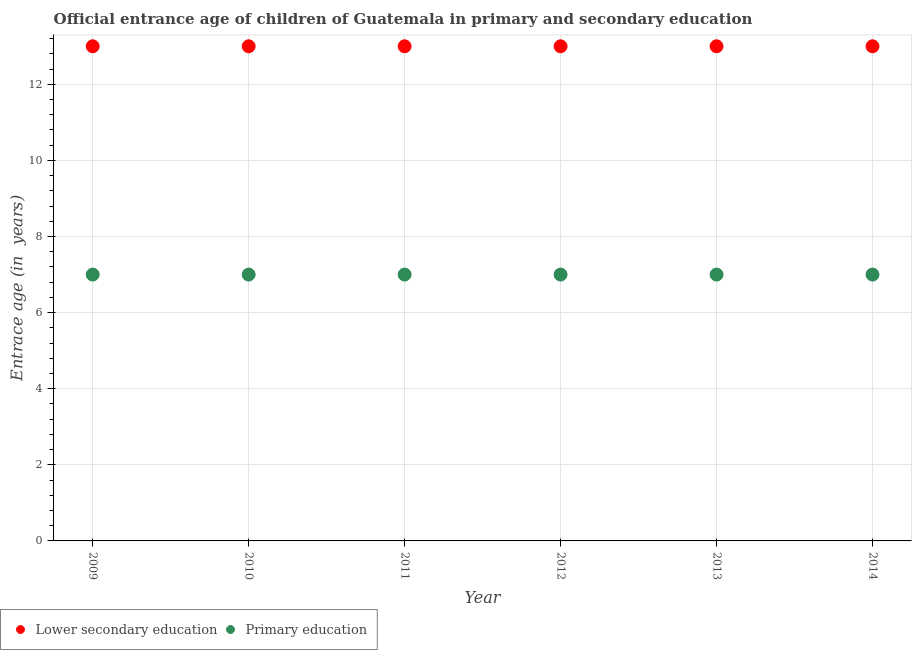Is the number of dotlines equal to the number of legend labels?
Your answer should be compact. Yes. What is the entrance age of children in lower secondary education in 2011?
Provide a short and direct response. 13. Across all years, what is the maximum entrance age of chiildren in primary education?
Keep it short and to the point. 7. Across all years, what is the minimum entrance age of children in lower secondary education?
Make the answer very short. 13. In which year was the entrance age of chiildren in primary education maximum?
Your response must be concise. 2009. In which year was the entrance age of chiildren in primary education minimum?
Provide a short and direct response. 2009. What is the total entrance age of children in lower secondary education in the graph?
Provide a short and direct response. 78. In the year 2011, what is the difference between the entrance age of children in lower secondary education and entrance age of chiildren in primary education?
Your answer should be compact. 6. In how many years, is the entrance age of chiildren in primary education greater than 7.6 years?
Provide a succinct answer. 0. What is the ratio of the entrance age of children in lower secondary education in 2011 to that in 2012?
Provide a short and direct response. 1. What is the difference between the highest and the second highest entrance age of chiildren in primary education?
Provide a succinct answer. 0. What is the difference between the highest and the lowest entrance age of chiildren in primary education?
Provide a succinct answer. 0. In how many years, is the entrance age of children in lower secondary education greater than the average entrance age of children in lower secondary education taken over all years?
Make the answer very short. 0. Does the entrance age of children in lower secondary education monotonically increase over the years?
Your answer should be compact. No. Is the entrance age of chiildren in primary education strictly greater than the entrance age of children in lower secondary education over the years?
Ensure brevity in your answer.  No. Is the entrance age of children in lower secondary education strictly less than the entrance age of chiildren in primary education over the years?
Your answer should be compact. No. How many dotlines are there?
Your answer should be compact. 2. Are the values on the major ticks of Y-axis written in scientific E-notation?
Keep it short and to the point. No. Does the graph contain grids?
Provide a short and direct response. Yes. How many legend labels are there?
Give a very brief answer. 2. What is the title of the graph?
Your answer should be very brief. Official entrance age of children of Guatemala in primary and secondary education. What is the label or title of the Y-axis?
Provide a succinct answer. Entrace age (in  years). What is the Entrace age (in  years) in Primary education in 2009?
Keep it short and to the point. 7. What is the Entrace age (in  years) in Primary education in 2010?
Offer a very short reply. 7. What is the Entrace age (in  years) in Lower secondary education in 2012?
Make the answer very short. 13. What is the Entrace age (in  years) in Primary education in 2012?
Ensure brevity in your answer.  7. What is the Entrace age (in  years) of Primary education in 2013?
Ensure brevity in your answer.  7. What is the Entrace age (in  years) of Primary education in 2014?
Your answer should be compact. 7. Across all years, what is the maximum Entrace age (in  years) in Lower secondary education?
Your answer should be compact. 13. What is the difference between the Entrace age (in  years) in Lower secondary education in 2009 and that in 2011?
Your answer should be compact. 0. What is the difference between the Entrace age (in  years) in Primary education in 2009 and that in 2013?
Provide a succinct answer. 0. What is the difference between the Entrace age (in  years) of Primary education in 2009 and that in 2014?
Keep it short and to the point. 0. What is the difference between the Entrace age (in  years) of Primary education in 2010 and that in 2011?
Your response must be concise. 0. What is the difference between the Entrace age (in  years) of Lower secondary education in 2010 and that in 2012?
Provide a succinct answer. 0. What is the difference between the Entrace age (in  years) of Lower secondary education in 2010 and that in 2013?
Your answer should be very brief. 0. What is the difference between the Entrace age (in  years) in Lower secondary education in 2010 and that in 2014?
Offer a terse response. 0. What is the difference between the Entrace age (in  years) of Primary education in 2010 and that in 2014?
Your answer should be very brief. 0. What is the difference between the Entrace age (in  years) in Lower secondary education in 2011 and that in 2013?
Your answer should be very brief. 0. What is the difference between the Entrace age (in  years) in Primary education in 2011 and that in 2013?
Your response must be concise. 0. What is the difference between the Entrace age (in  years) in Primary education in 2012 and that in 2013?
Your answer should be compact. 0. What is the difference between the Entrace age (in  years) in Lower secondary education in 2012 and that in 2014?
Give a very brief answer. 0. What is the difference between the Entrace age (in  years) in Lower secondary education in 2013 and that in 2014?
Offer a very short reply. 0. What is the difference between the Entrace age (in  years) of Lower secondary education in 2009 and the Entrace age (in  years) of Primary education in 2010?
Offer a terse response. 6. What is the difference between the Entrace age (in  years) in Lower secondary education in 2009 and the Entrace age (in  years) in Primary education in 2011?
Keep it short and to the point. 6. What is the difference between the Entrace age (in  years) in Lower secondary education in 2010 and the Entrace age (in  years) in Primary education in 2011?
Ensure brevity in your answer.  6. What is the difference between the Entrace age (in  years) of Lower secondary education in 2010 and the Entrace age (in  years) of Primary education in 2012?
Ensure brevity in your answer.  6. What is the difference between the Entrace age (in  years) of Lower secondary education in 2011 and the Entrace age (in  years) of Primary education in 2014?
Your answer should be compact. 6. What is the difference between the Entrace age (in  years) of Lower secondary education in 2012 and the Entrace age (in  years) of Primary education in 2013?
Give a very brief answer. 6. What is the difference between the Entrace age (in  years) of Lower secondary education in 2012 and the Entrace age (in  years) of Primary education in 2014?
Provide a succinct answer. 6. What is the average Entrace age (in  years) of Lower secondary education per year?
Give a very brief answer. 13. What is the average Entrace age (in  years) in Primary education per year?
Ensure brevity in your answer.  7. In the year 2009, what is the difference between the Entrace age (in  years) in Lower secondary education and Entrace age (in  years) in Primary education?
Keep it short and to the point. 6. In the year 2010, what is the difference between the Entrace age (in  years) of Lower secondary education and Entrace age (in  years) of Primary education?
Give a very brief answer. 6. In the year 2011, what is the difference between the Entrace age (in  years) in Lower secondary education and Entrace age (in  years) in Primary education?
Make the answer very short. 6. In the year 2013, what is the difference between the Entrace age (in  years) of Lower secondary education and Entrace age (in  years) of Primary education?
Make the answer very short. 6. In the year 2014, what is the difference between the Entrace age (in  years) in Lower secondary education and Entrace age (in  years) in Primary education?
Keep it short and to the point. 6. What is the ratio of the Entrace age (in  years) of Primary education in 2009 to that in 2010?
Ensure brevity in your answer.  1. What is the ratio of the Entrace age (in  years) of Primary education in 2009 to that in 2011?
Ensure brevity in your answer.  1. What is the ratio of the Entrace age (in  years) in Primary education in 2009 to that in 2012?
Provide a short and direct response. 1. What is the ratio of the Entrace age (in  years) of Lower secondary education in 2009 to that in 2014?
Keep it short and to the point. 1. What is the ratio of the Entrace age (in  years) of Primary education in 2009 to that in 2014?
Provide a short and direct response. 1. What is the ratio of the Entrace age (in  years) of Lower secondary education in 2010 to that in 2011?
Your answer should be compact. 1. What is the ratio of the Entrace age (in  years) in Primary education in 2010 to that in 2012?
Provide a succinct answer. 1. What is the ratio of the Entrace age (in  years) in Lower secondary education in 2010 to that in 2013?
Offer a terse response. 1. What is the ratio of the Entrace age (in  years) in Lower secondary education in 2010 to that in 2014?
Provide a short and direct response. 1. What is the ratio of the Entrace age (in  years) in Primary education in 2011 to that in 2012?
Provide a succinct answer. 1. What is the ratio of the Entrace age (in  years) of Lower secondary education in 2011 to that in 2013?
Your answer should be very brief. 1. What is the ratio of the Entrace age (in  years) of Primary education in 2011 to that in 2014?
Make the answer very short. 1. What is the ratio of the Entrace age (in  years) of Lower secondary education in 2012 to that in 2014?
Offer a very short reply. 1. What is the ratio of the Entrace age (in  years) of Primary education in 2013 to that in 2014?
Offer a very short reply. 1. What is the difference between the highest and the lowest Entrace age (in  years) in Lower secondary education?
Your answer should be very brief. 0. What is the difference between the highest and the lowest Entrace age (in  years) of Primary education?
Your answer should be very brief. 0. 